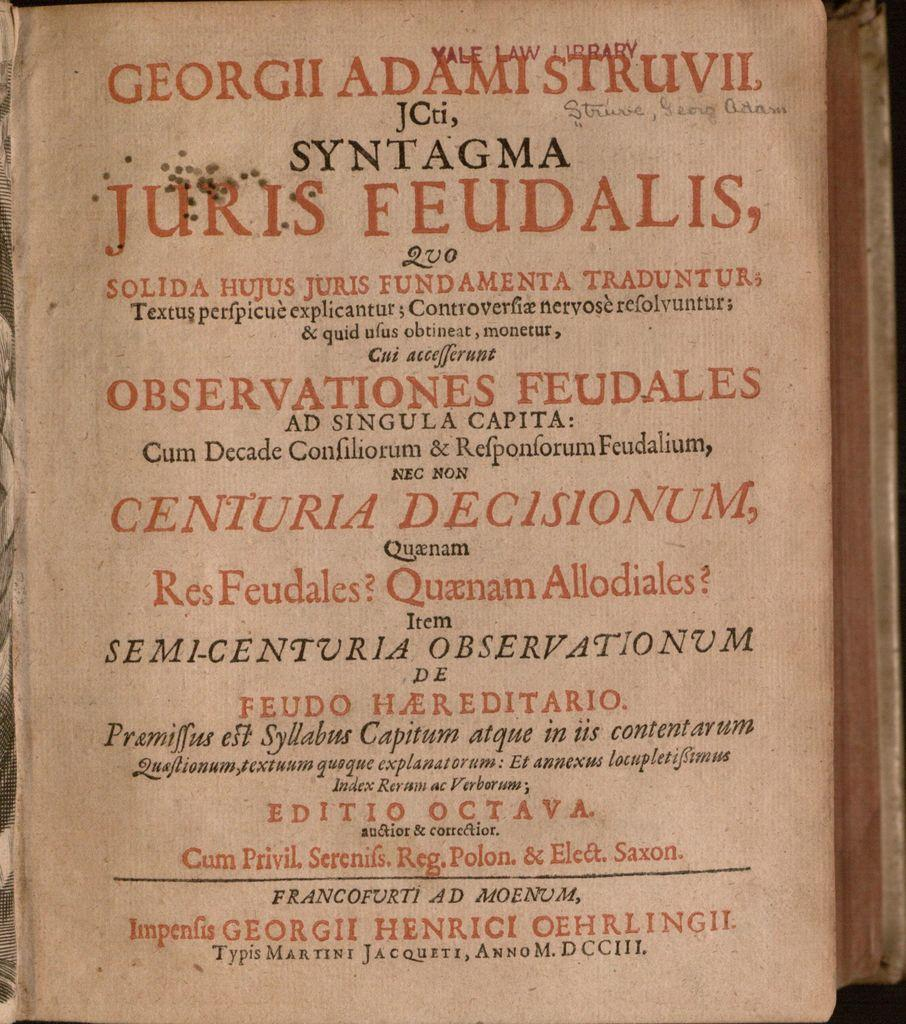<image>
Render a clear and concise summary of the photo. a page that says it is from the yale law library 